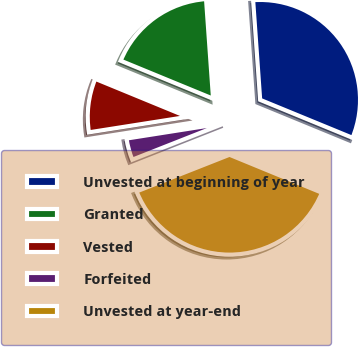<chart> <loc_0><loc_0><loc_500><loc_500><pie_chart><fcel>Unvested at beginning of year<fcel>Granted<fcel>Vested<fcel>Forfeited<fcel>Unvested at year-end<nl><fcel>32.33%<fcel>17.67%<fcel>8.69%<fcel>3.5%<fcel>37.82%<nl></chart> 